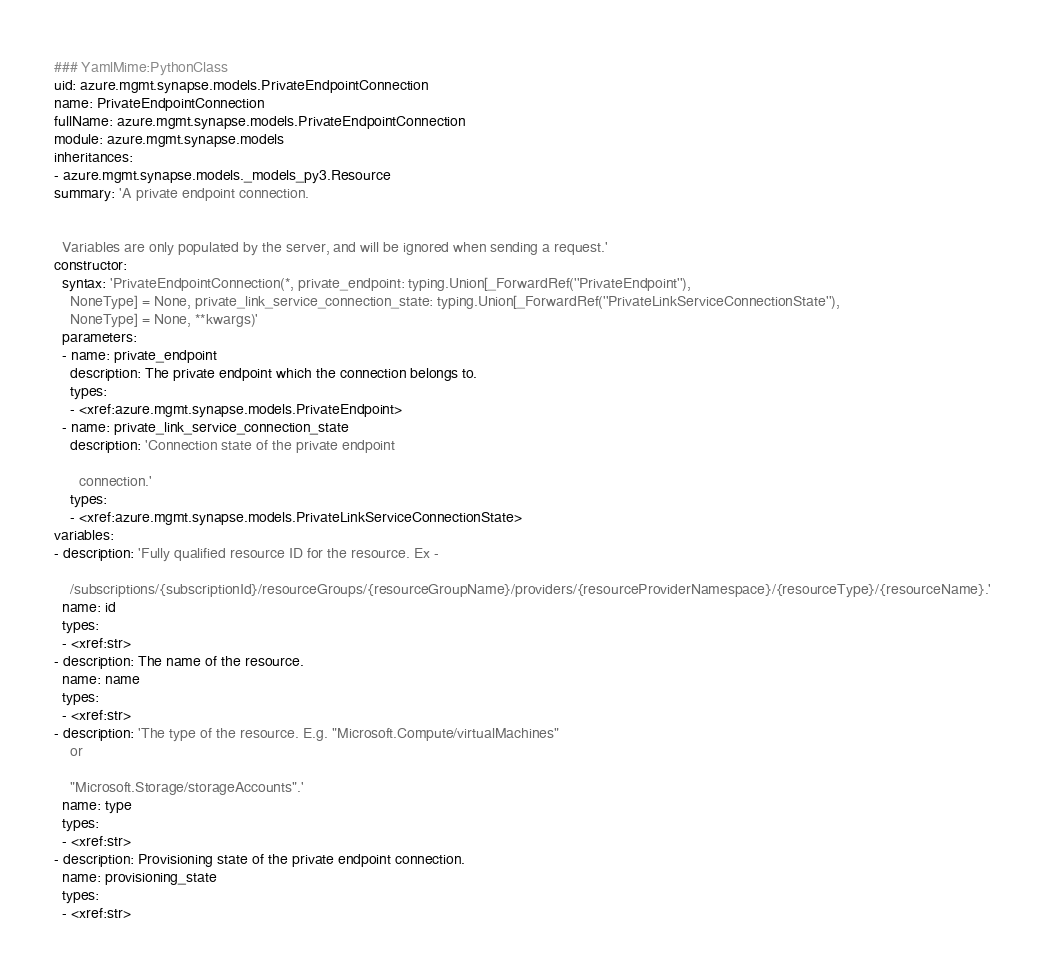Convert code to text. <code><loc_0><loc_0><loc_500><loc_500><_YAML_>### YamlMime:PythonClass
uid: azure.mgmt.synapse.models.PrivateEndpointConnection
name: PrivateEndpointConnection
fullName: azure.mgmt.synapse.models.PrivateEndpointConnection
module: azure.mgmt.synapse.models
inheritances:
- azure.mgmt.synapse.models._models_py3.Resource
summary: 'A private endpoint connection.


  Variables are only populated by the server, and will be ignored when sending a request.'
constructor:
  syntax: 'PrivateEndpointConnection(*, private_endpoint: typing.Union[_ForwardRef(''PrivateEndpoint''),
    NoneType] = None, private_link_service_connection_state: typing.Union[_ForwardRef(''PrivateLinkServiceConnectionState''),
    NoneType] = None, **kwargs)'
  parameters:
  - name: private_endpoint
    description: The private endpoint which the connection belongs to.
    types:
    - <xref:azure.mgmt.synapse.models.PrivateEndpoint>
  - name: private_link_service_connection_state
    description: 'Connection state of the private endpoint

      connection.'
    types:
    - <xref:azure.mgmt.synapse.models.PrivateLinkServiceConnectionState>
variables:
- description: 'Fully qualified resource ID for the resource. Ex -

    /subscriptions/{subscriptionId}/resourceGroups/{resourceGroupName}/providers/{resourceProviderNamespace}/{resourceType}/{resourceName}.'
  name: id
  types:
  - <xref:str>
- description: The name of the resource.
  name: name
  types:
  - <xref:str>
- description: 'The type of the resource. E.g. "Microsoft.Compute/virtualMachines"
    or

    "Microsoft.Storage/storageAccounts".'
  name: type
  types:
  - <xref:str>
- description: Provisioning state of the private endpoint connection.
  name: provisioning_state
  types:
  - <xref:str>
</code> 